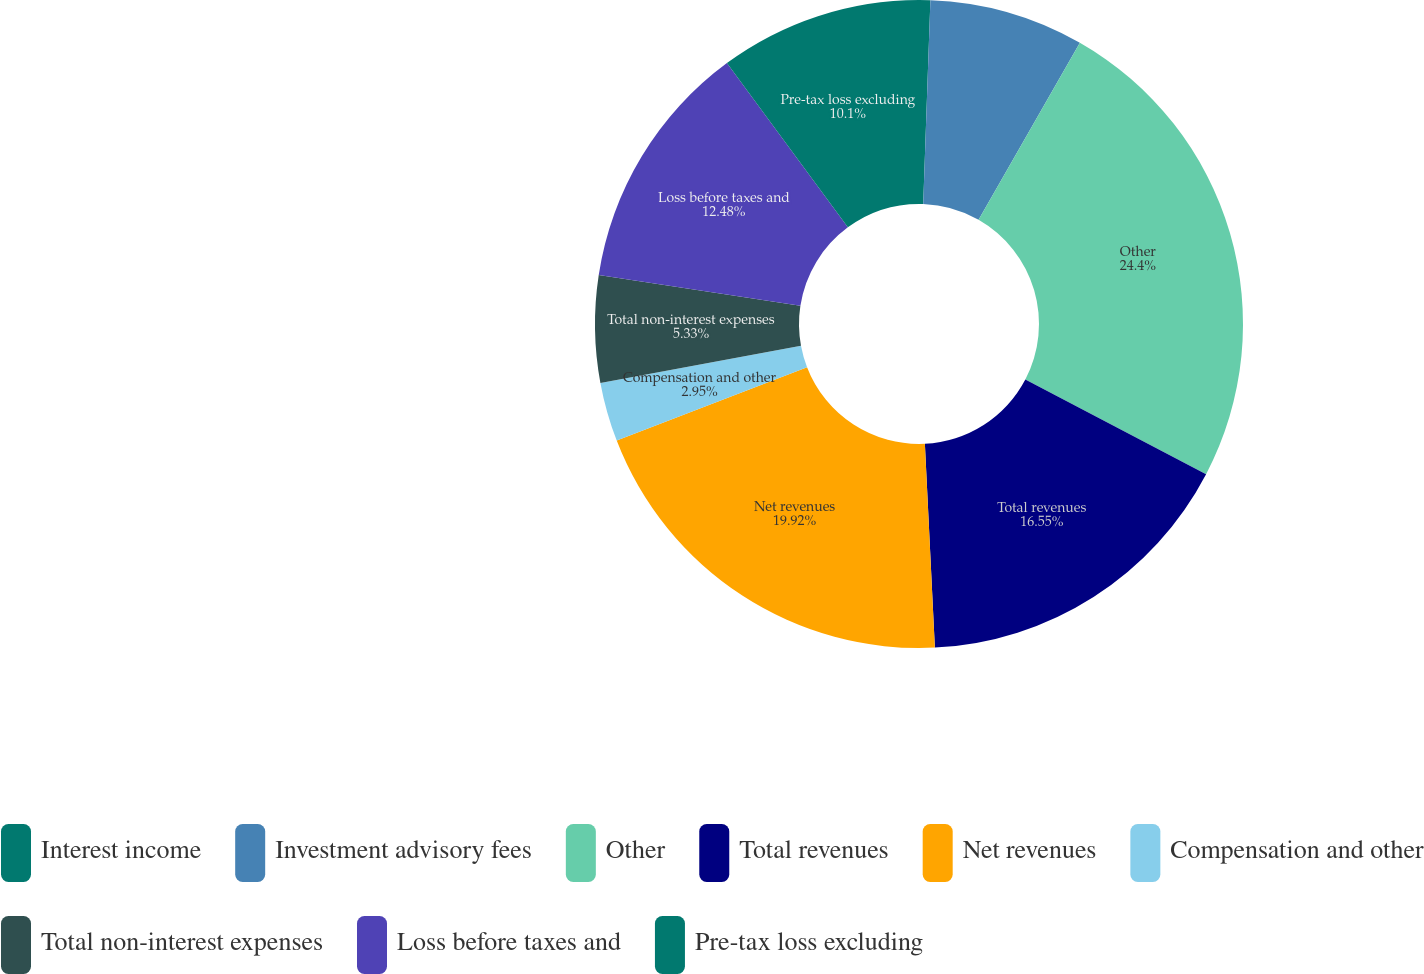Convert chart. <chart><loc_0><loc_0><loc_500><loc_500><pie_chart><fcel>Interest income<fcel>Investment advisory fees<fcel>Other<fcel>Total revenues<fcel>Net revenues<fcel>Compensation and other<fcel>Total non-interest expenses<fcel>Loss before taxes and<fcel>Pre-tax loss excluding<nl><fcel>0.56%<fcel>7.71%<fcel>24.4%<fcel>16.55%<fcel>19.92%<fcel>2.95%<fcel>5.33%<fcel>12.48%<fcel>10.1%<nl></chart> 